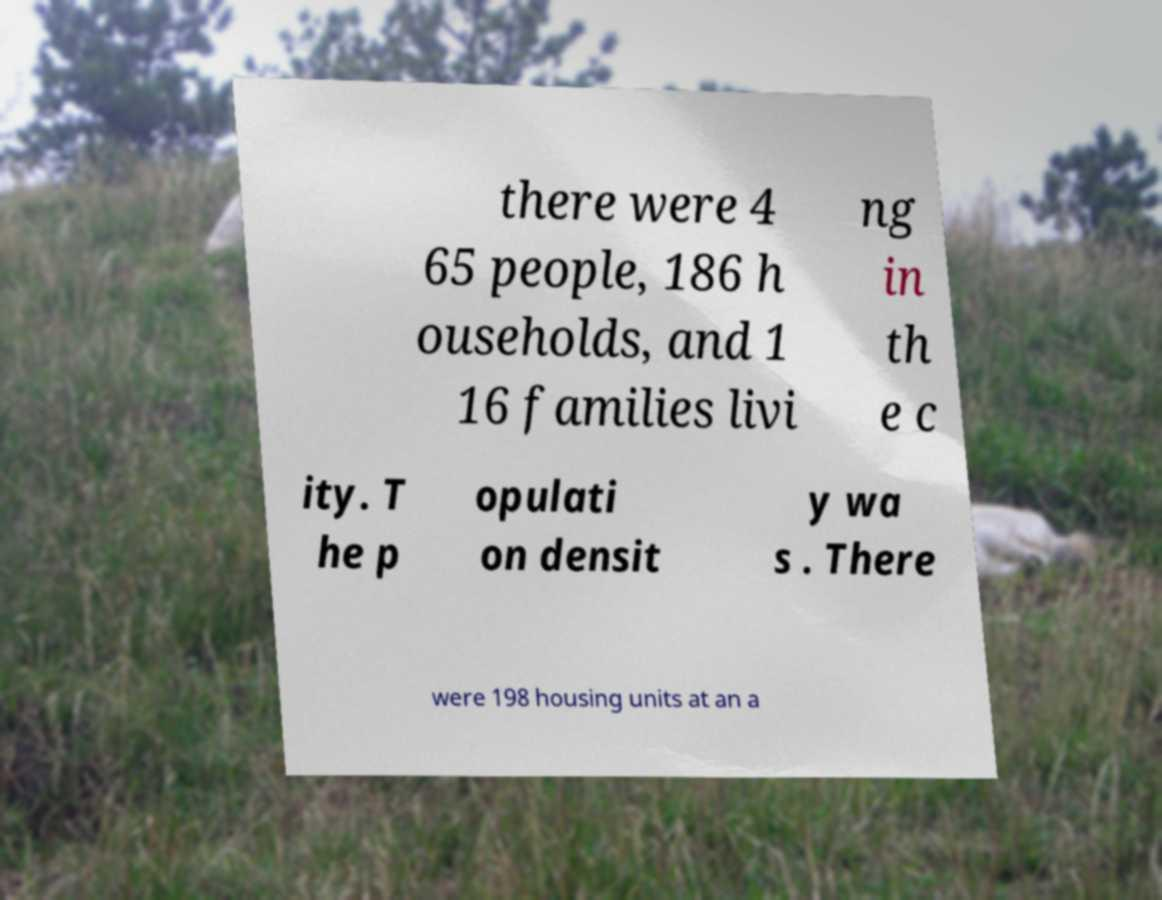For documentation purposes, I need the text within this image transcribed. Could you provide that? there were 4 65 people, 186 h ouseholds, and 1 16 families livi ng in th e c ity. T he p opulati on densit y wa s . There were 198 housing units at an a 